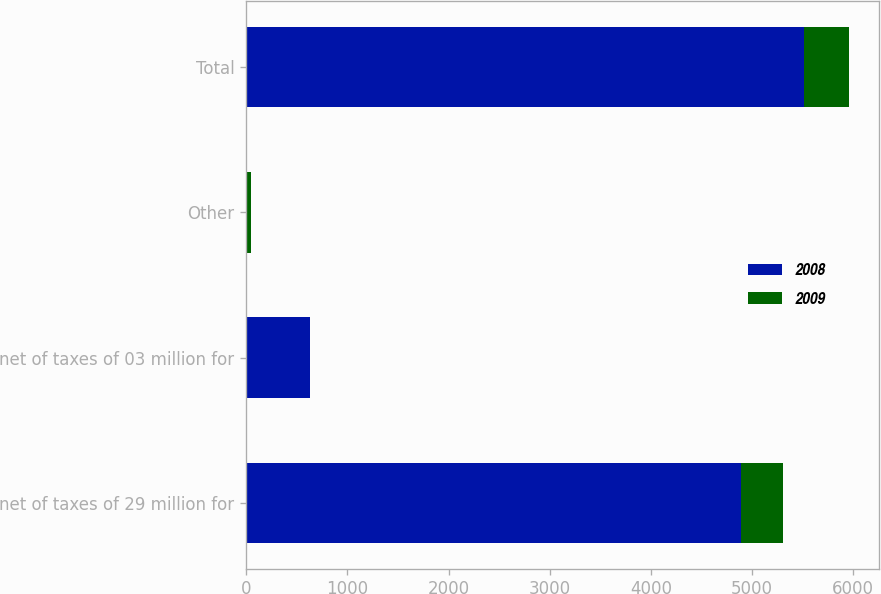Convert chart to OTSL. <chart><loc_0><loc_0><loc_500><loc_500><stacked_bar_chart><ecel><fcel>net of taxes of 29 million for<fcel>net of taxes of 03 million for<fcel>Other<fcel>Total<nl><fcel>2008<fcel>4890<fcel>628<fcel>9<fcel>5509<nl><fcel>2009<fcel>416<fcel>7<fcel>36<fcel>445<nl></chart> 